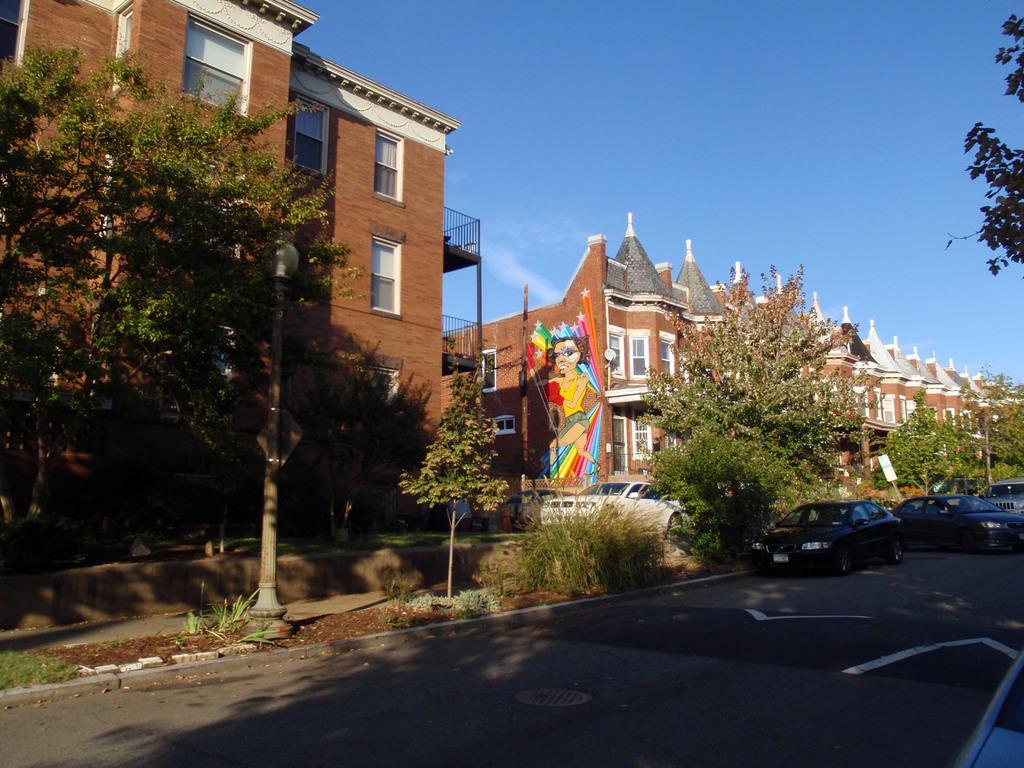How would you summarize this image in a sentence or two? In this picture there are buildings, trees and poles and there are vehicles on the road and there is a painting of a woman on the wall. At the top there is sky and there are clouds. At the bottom there is a road and there is mud and there are plants 